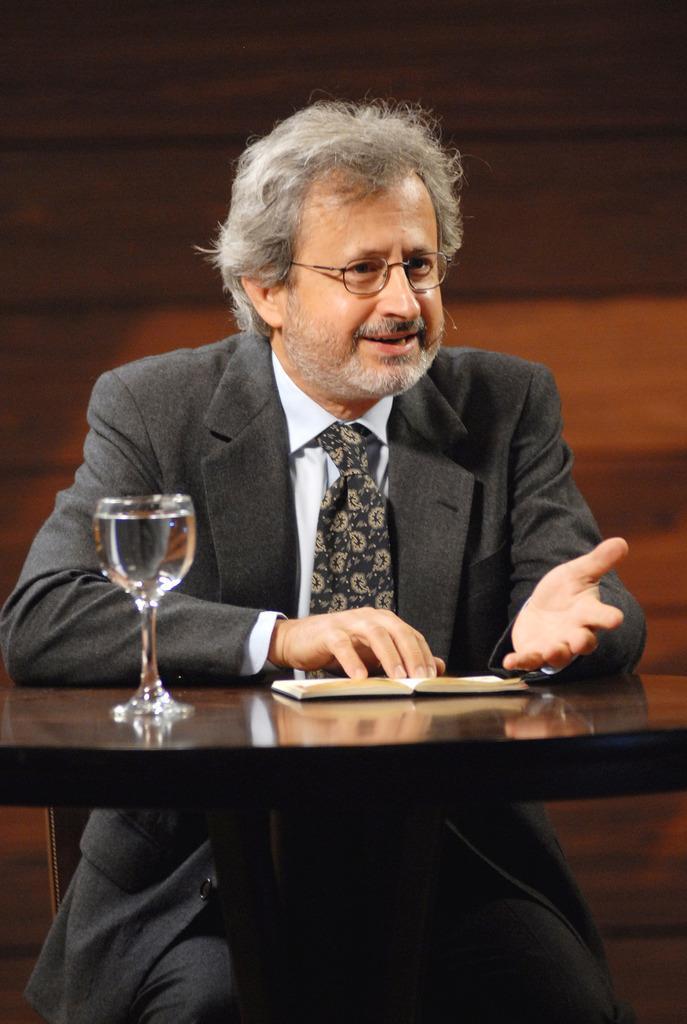In one or two sentences, can you explain what this image depicts? In this image i can see a person wearing a black color jacket, his mouth is open ,wearing a spectacles ,sitting in front of the table ,there is a glass container with water and there is a book on the table. 